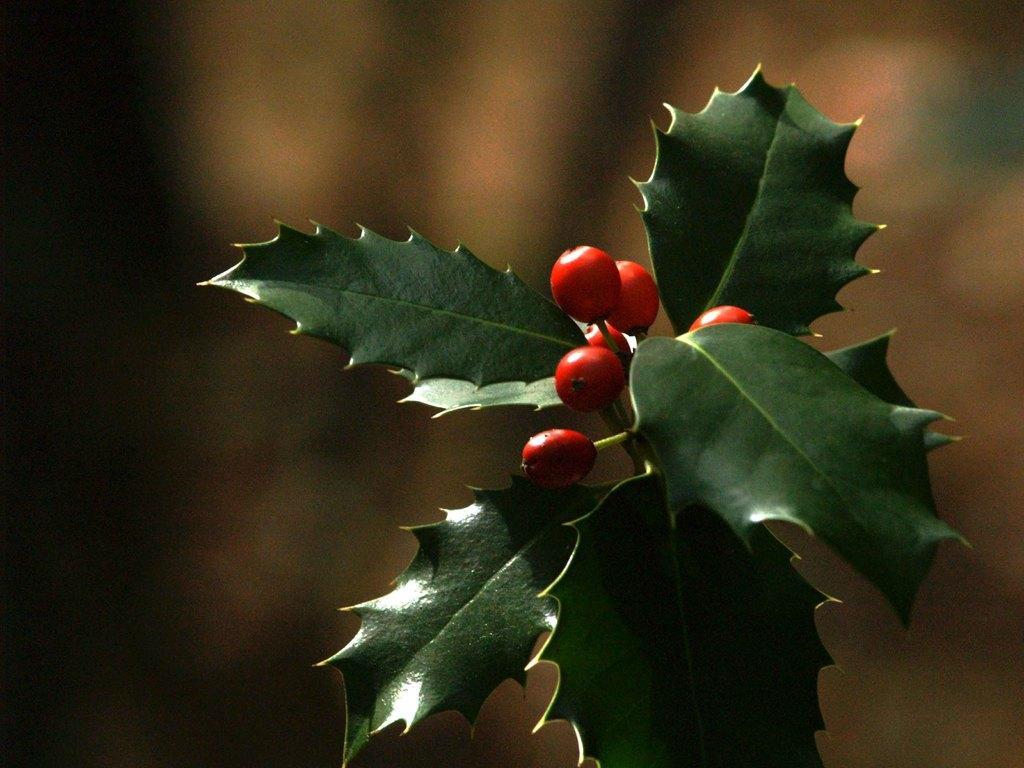Could you give a brief overview of what you see in this image? In the picture we can see a plant with fruits which are red in color with leaves. 